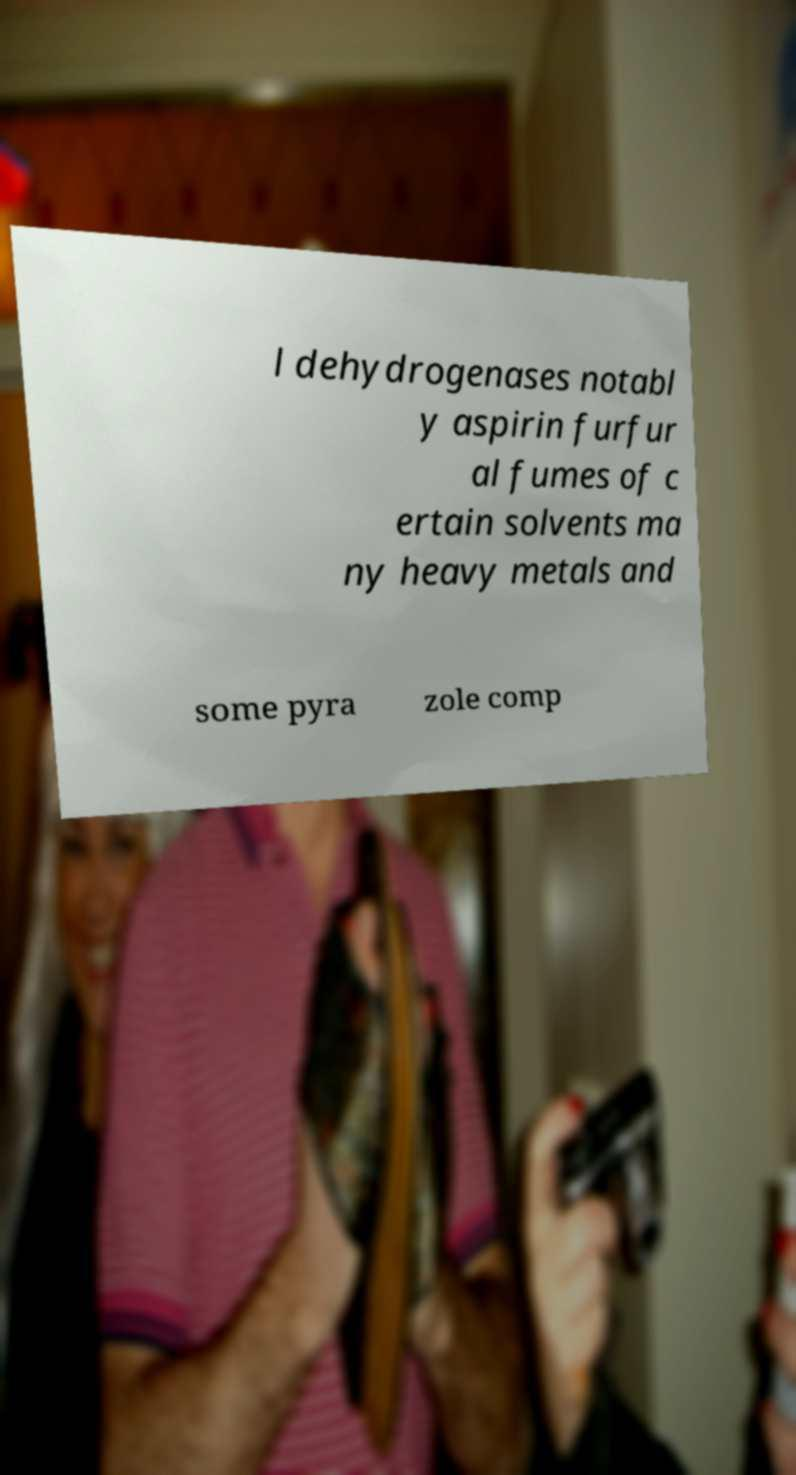Please read and relay the text visible in this image. What does it say? l dehydrogenases notabl y aspirin furfur al fumes of c ertain solvents ma ny heavy metals and some pyra zole comp 